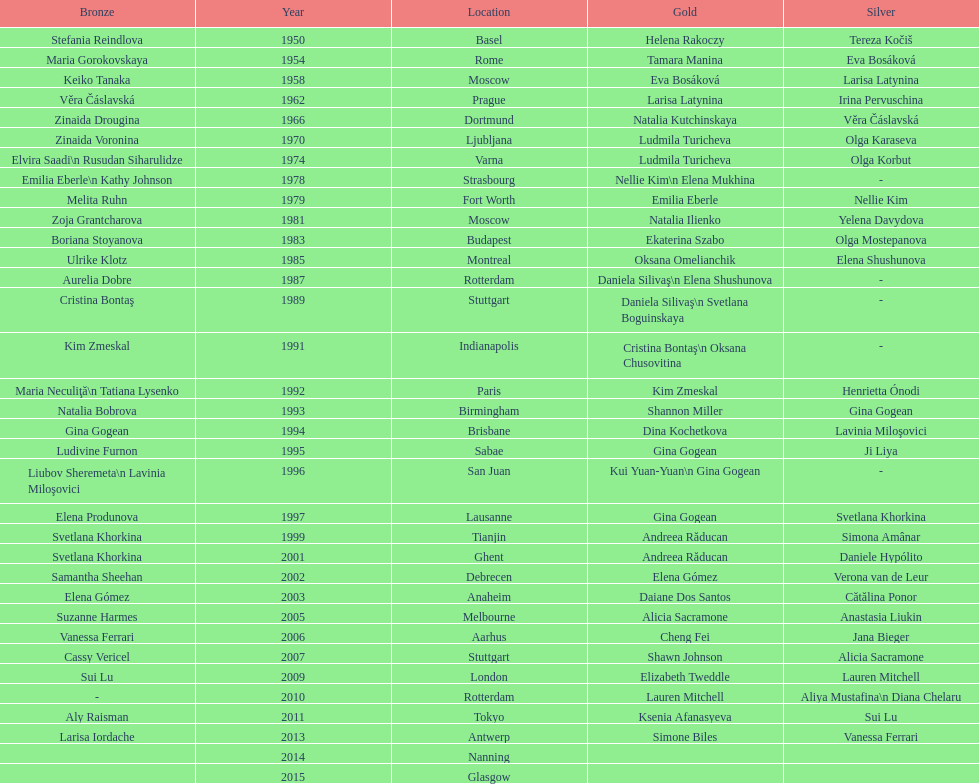How many times was the world artistic gymnastics championships held in the united states? 3. 